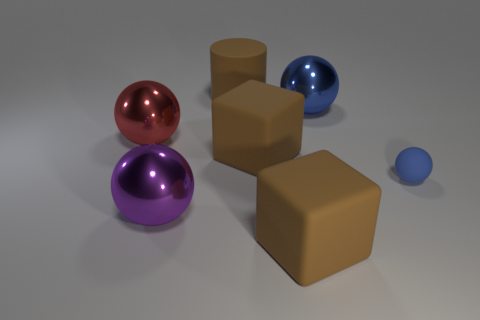Is there any other thing that is the same size as the rubber ball?
Provide a succinct answer. No. Is there a blue shiny sphere behind the big brown thing that is behind the red thing?
Your response must be concise. No. There is a sphere behind the large red metal object; does it have the same size as the rubber cube behind the tiny rubber sphere?
Ensure brevity in your answer.  Yes. How many big objects are brown matte objects or cubes?
Keep it short and to the point. 3. There is a large brown cube that is behind the big block in front of the purple metal object; what is its material?
Your answer should be very brief. Rubber. There is a large thing that is the same color as the small matte sphere; what shape is it?
Provide a short and direct response. Sphere. Is there a small thing that has the same material as the big brown cylinder?
Offer a very short reply. Yes. Does the red sphere have the same material as the brown block that is in front of the small blue rubber ball?
Your response must be concise. No. There is a cylinder that is the same size as the purple metallic object; what is its color?
Make the answer very short. Brown. What size is the block that is on the left side of the large brown rubber object that is in front of the big purple ball?
Offer a very short reply. Large. 